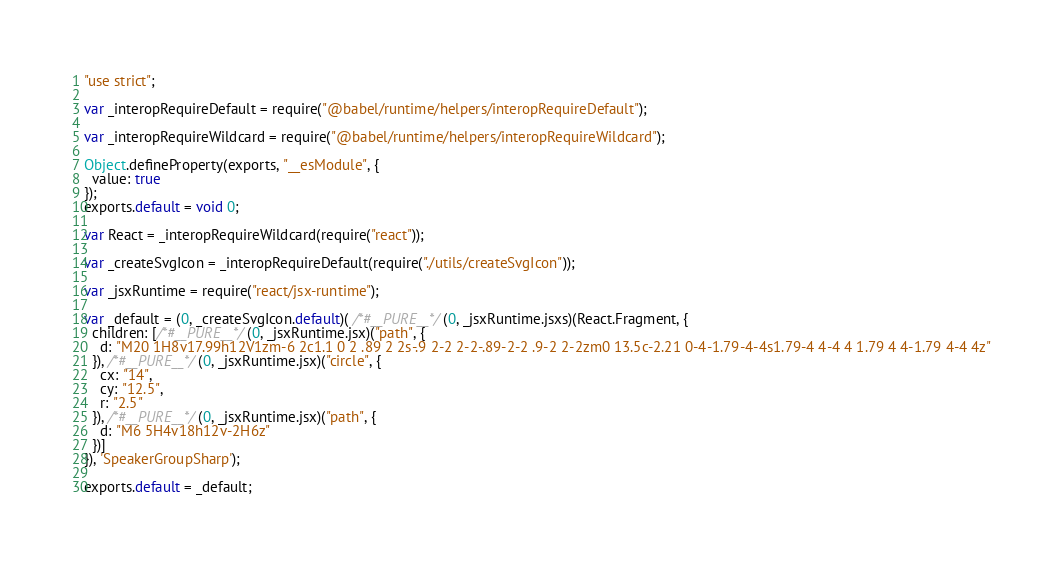<code> <loc_0><loc_0><loc_500><loc_500><_JavaScript_>"use strict";

var _interopRequireDefault = require("@babel/runtime/helpers/interopRequireDefault");

var _interopRequireWildcard = require("@babel/runtime/helpers/interopRequireWildcard");

Object.defineProperty(exports, "__esModule", {
  value: true
});
exports.default = void 0;

var React = _interopRequireWildcard(require("react"));

var _createSvgIcon = _interopRequireDefault(require("./utils/createSvgIcon"));

var _jsxRuntime = require("react/jsx-runtime");

var _default = (0, _createSvgIcon.default)( /*#__PURE__*/(0, _jsxRuntime.jsxs)(React.Fragment, {
  children: [/*#__PURE__*/(0, _jsxRuntime.jsx)("path", {
    d: "M20 1H8v17.99h12V1zm-6 2c1.1 0 2 .89 2 2s-.9 2-2 2-2-.89-2-2 .9-2 2-2zm0 13.5c-2.21 0-4-1.79-4-4s1.79-4 4-4 4 1.79 4 4-1.79 4-4 4z"
  }), /*#__PURE__*/(0, _jsxRuntime.jsx)("circle", {
    cx: "14",
    cy: "12.5",
    r: "2.5"
  }), /*#__PURE__*/(0, _jsxRuntime.jsx)("path", {
    d: "M6 5H4v18h12v-2H6z"
  })]
}), 'SpeakerGroupSharp');

exports.default = _default;</code> 